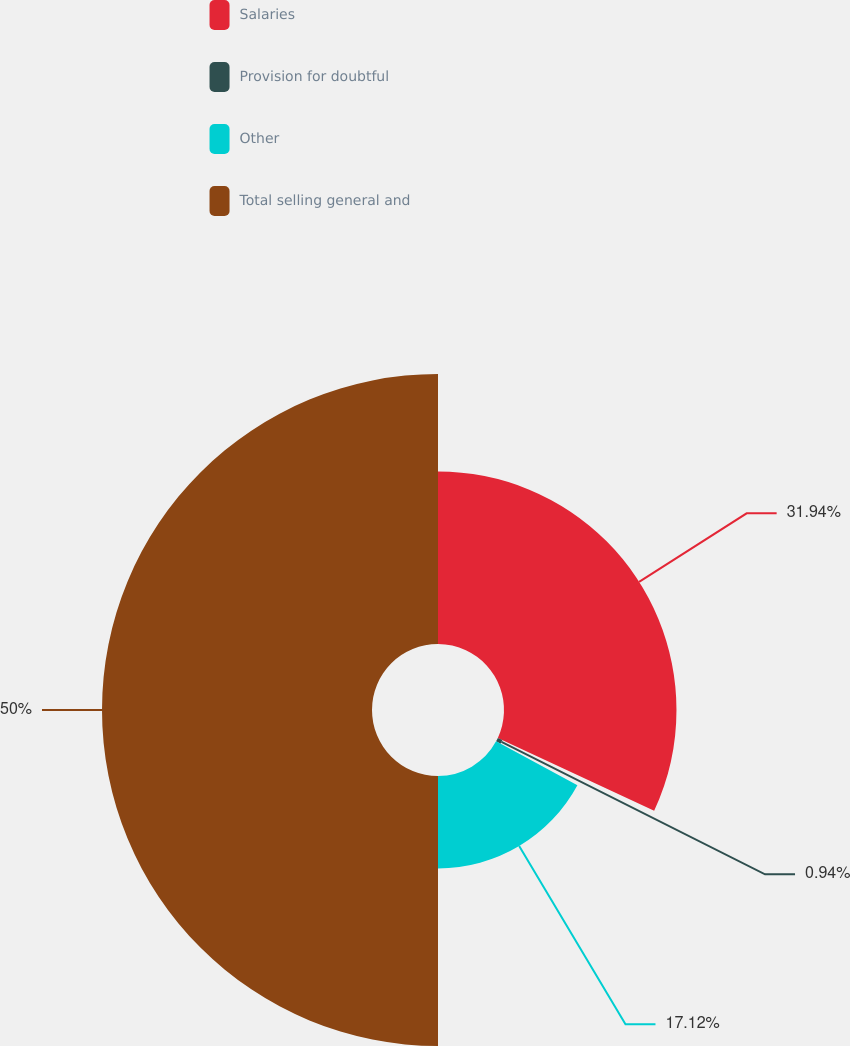Convert chart. <chart><loc_0><loc_0><loc_500><loc_500><pie_chart><fcel>Salaries<fcel>Provision for doubtful<fcel>Other<fcel>Total selling general and<nl><fcel>31.94%<fcel>0.94%<fcel>17.12%<fcel>50.0%<nl></chart> 